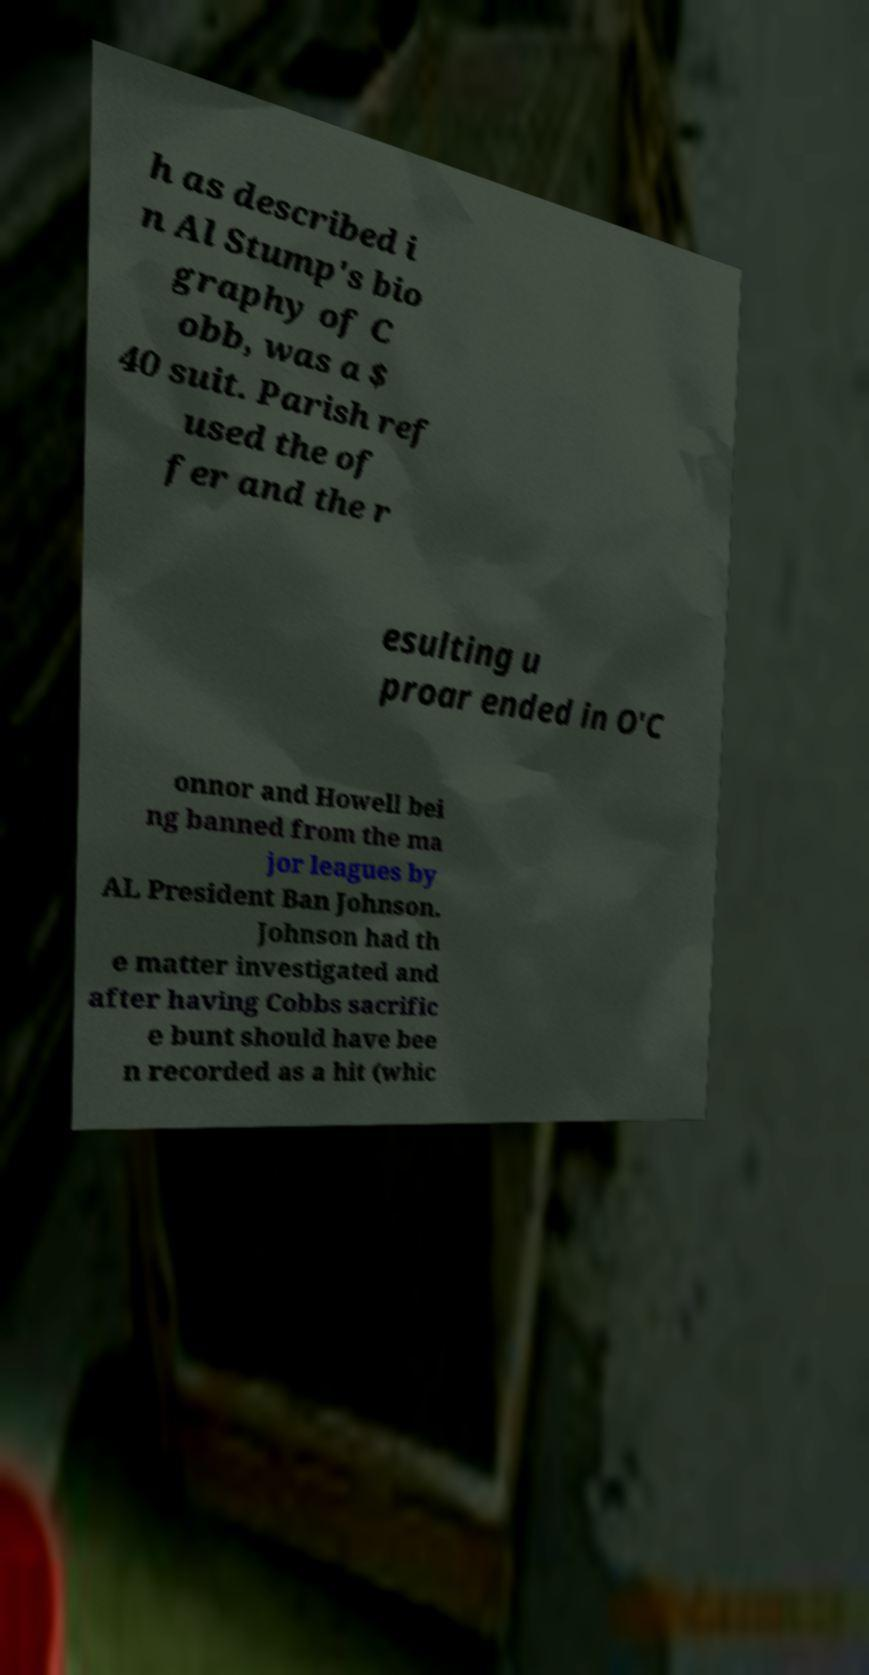Can you accurately transcribe the text from the provided image for me? h as described i n Al Stump's bio graphy of C obb, was a $ 40 suit. Parish ref used the of fer and the r esulting u proar ended in O'C onnor and Howell bei ng banned from the ma jor leagues by AL President Ban Johnson. Johnson had th e matter investigated and after having Cobbs sacrific e bunt should have bee n recorded as a hit (whic 